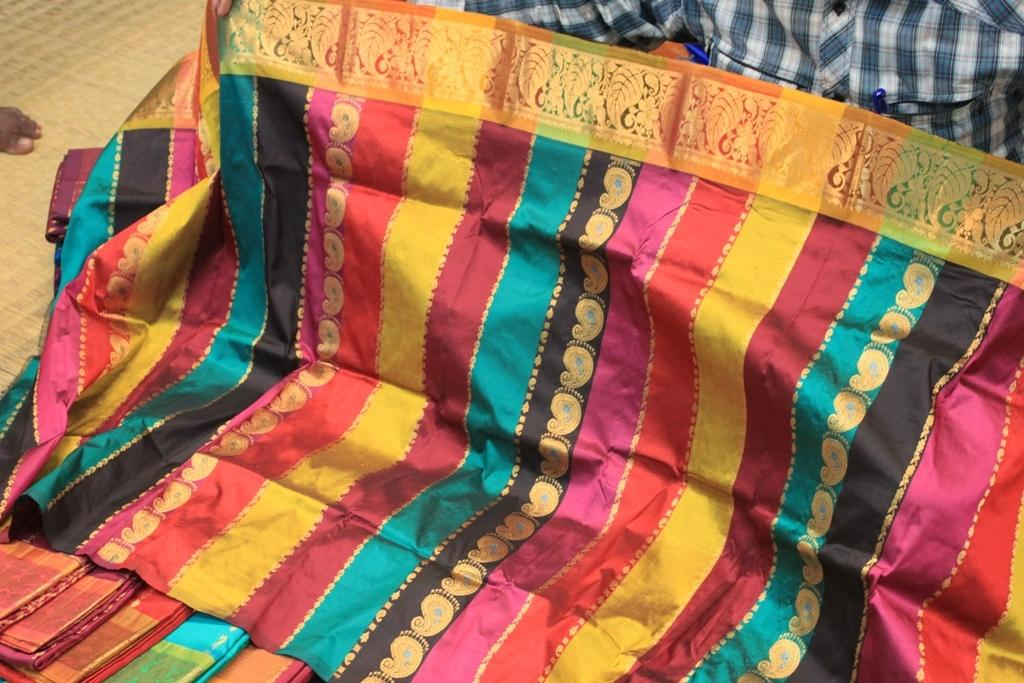What type of clothing is featured in the image? There is a saree with multicolor in the image, and there are many other sarees as well. Can you describe the person in the image? The person in the image is wearing a shirt. What object is the person carrying in their pocket? The person has a pen in their pocket. What type of bread can be seen in the image? There is no bread present in the image. How does the friction between the sarees affect the decision-making process of the person in the image? There is no mention of friction or decision-making in the image, so it is not possible to answer this question. 